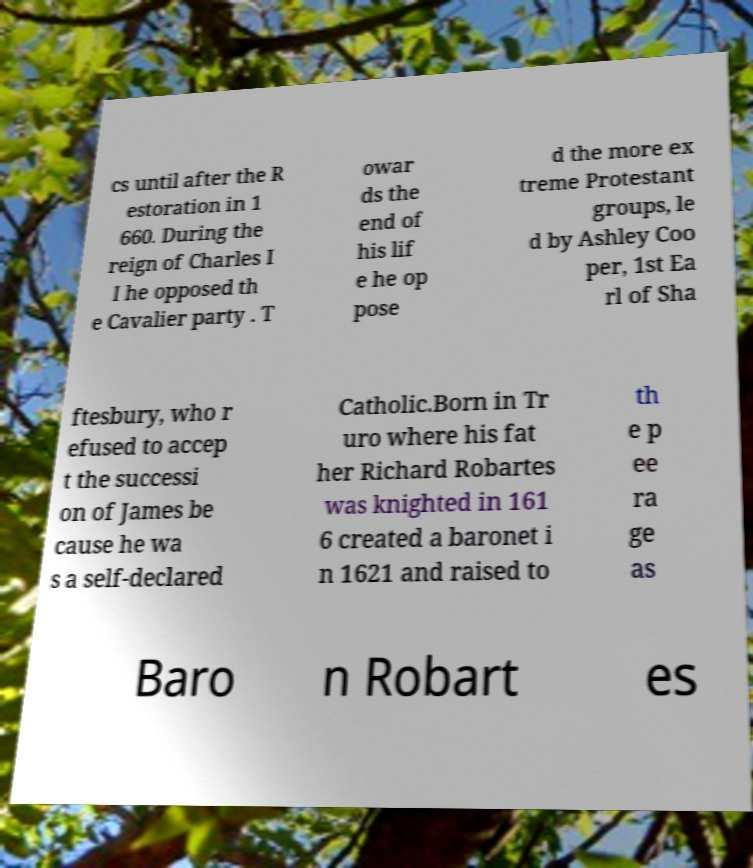What messages or text are displayed in this image? I need them in a readable, typed format. cs until after the R estoration in 1 660. During the reign of Charles I I he opposed th e Cavalier party . T owar ds the end of his lif e he op pose d the more ex treme Protestant groups, le d by Ashley Coo per, 1st Ea rl of Sha ftesbury, who r efused to accep t the successi on of James be cause he wa s a self-declared Catholic.Born in Tr uro where his fat her Richard Robartes was knighted in 161 6 created a baronet i n 1621 and raised to th e p ee ra ge as Baro n Robart es 